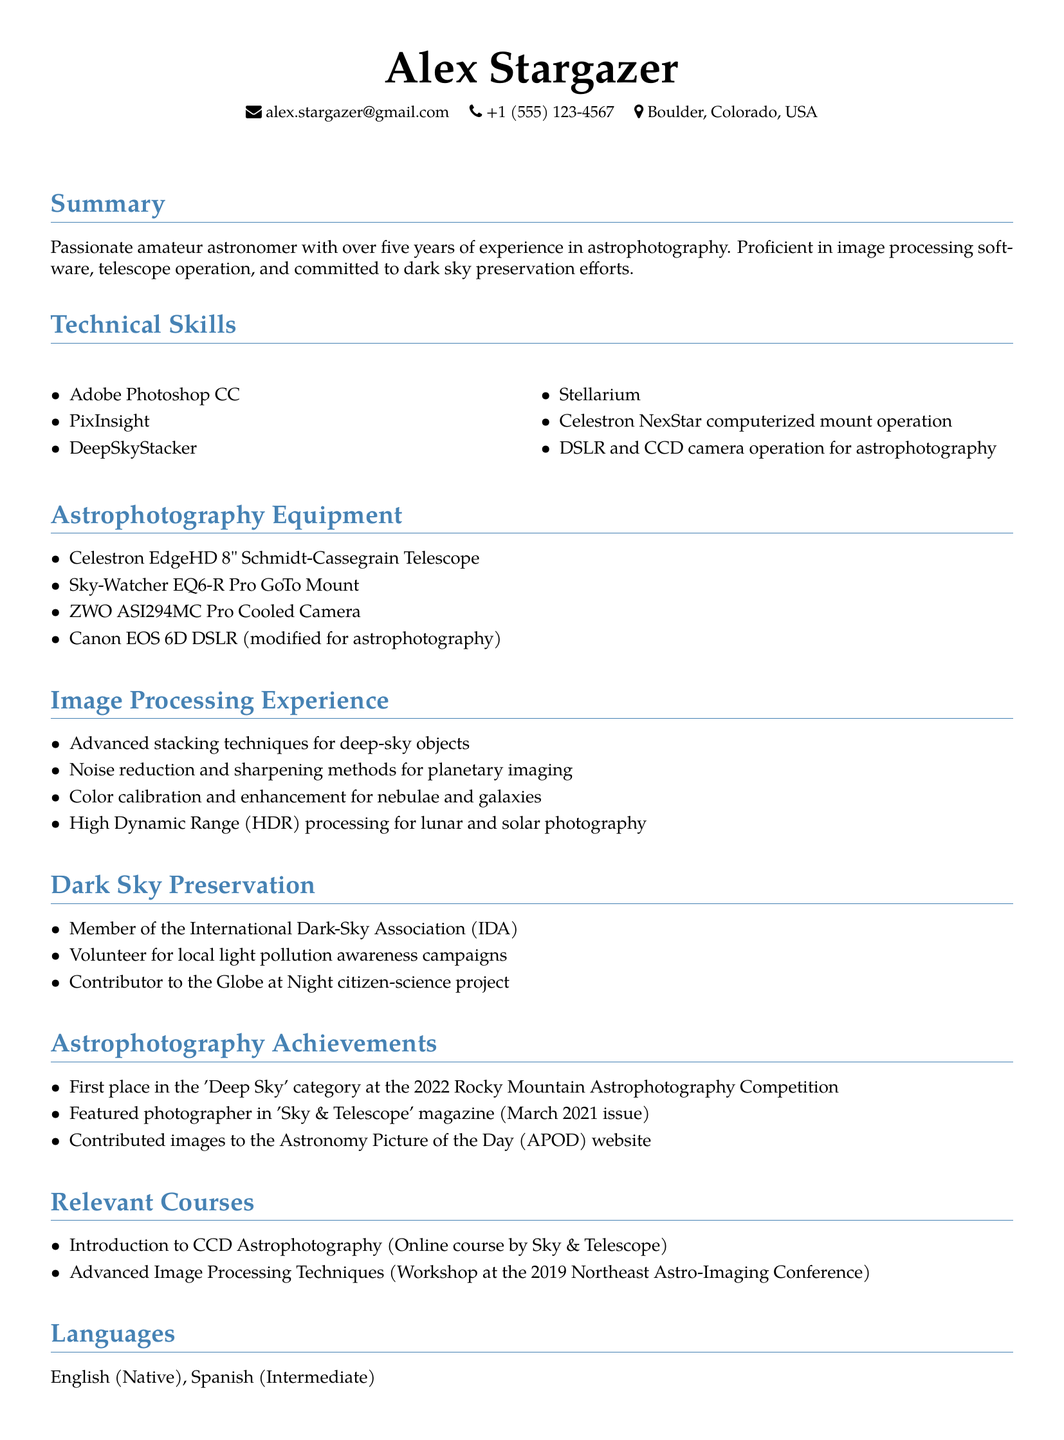What is the name of the individual? The individual's name is listed at the top of the document.
Answer: Alex Stargazer What is the location mentioned in the CV? The location indicates where the individual resides.
Answer: Boulder, Colorado, USA How many years of experience in astrophotography does Alex have? The summary outlines the total years of experience in the field of astrophotography.
Answer: Five years What is one of the image processing software listed? The technical skills section includes various software used for image processing.
Answer: Adobe Photoshop CC What telescope does Alex use? The astrophotography equipment section specifies the telescope model used.
Answer: Celestron EdgeHD 8" Schmidt-Cassegrain Telescope Which organization is Alex a member of? The dark sky preservation section mentions the organization Alex is affiliated with.
Answer: International Dark-Sky Association (IDA) What achievement did Alex earn at the 2022 Rocky Mountain Astrophotography Competition? The astrophotography achievements section highlights competitive recognition.
Answer: First place in the 'Deep Sky' category In what magazine was Alex featured? The achievements section specifically states where Alex's photography was featured.
Answer: Sky & Telescope What language is listed as Alex's intermediate proficiency? The languages section identifies Alex's language skills.
Answer: Spanish 